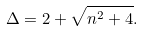<formula> <loc_0><loc_0><loc_500><loc_500>\Delta = 2 + \sqrt { n ^ { 2 } + 4 } .</formula> 